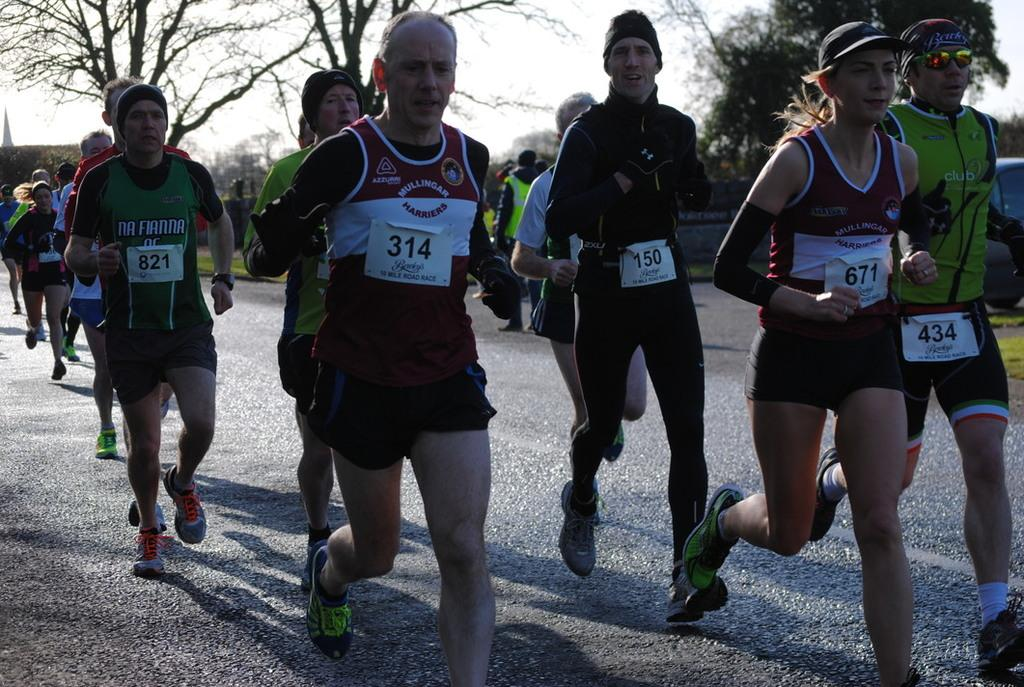What are the people in the image doing? The men and women in the image are jogging on the road. What can be seen in the background of the image? There are trees and the sky visible in the background of the image. What type of tin can be seen being used by the joggers in the image? There is no tin present in the image; the people are jogging on the road. What kind of cheese is being consumed by the joggers in the image? There is no cheese present in the image; the people are jogging on the road. 